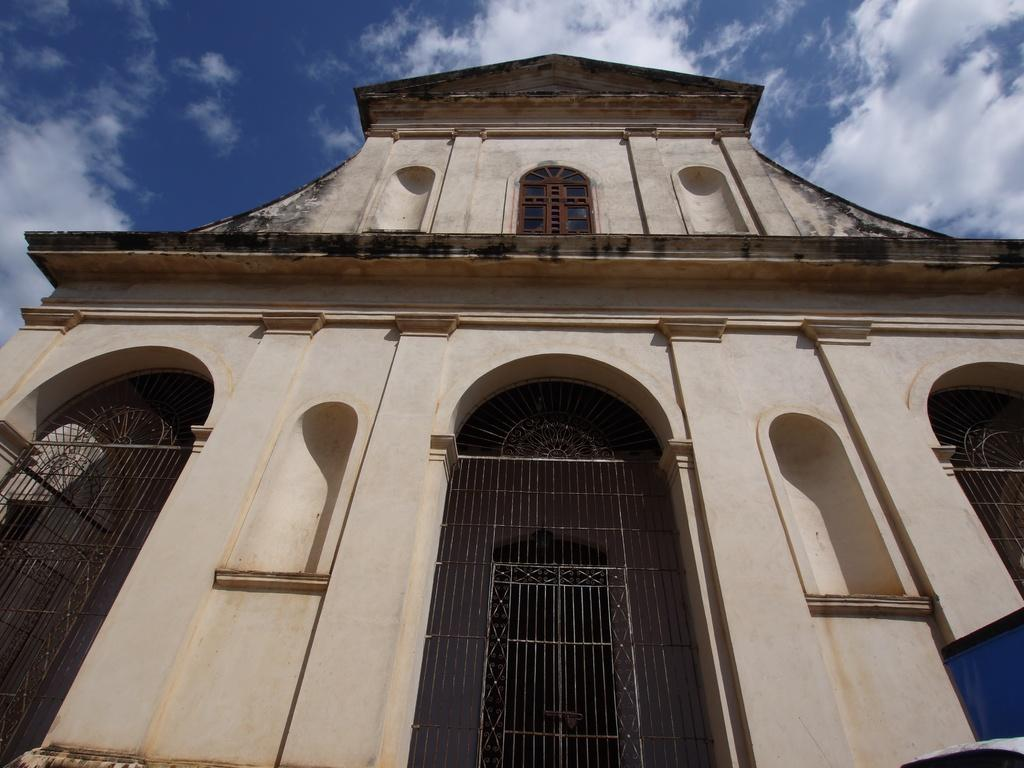What type of structure can be seen in the picture? There is a building in the picture. What can be seen in the sky in the picture? Clouds are visible in the sky. How many geese are flying in rhythm in the picture? There are no geese present in the image, and therefore no such activity can be observed. 